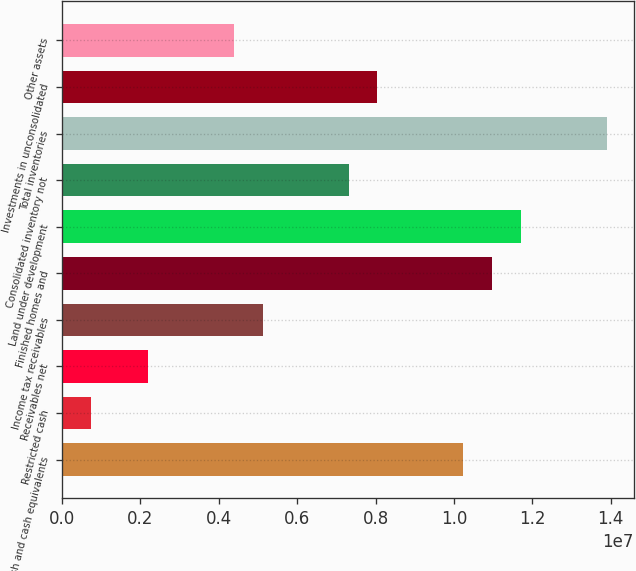Convert chart to OTSL. <chart><loc_0><loc_0><loc_500><loc_500><bar_chart><fcel>Cash and cash equivalents<fcel>Restricted cash<fcel>Receivables net<fcel>Income tax receivables<fcel>Finished homes and<fcel>Land under development<fcel>Consolidated inventory not<fcel>Total inventories<fcel>Investments in unconsolidated<fcel>Other assets<nl><fcel>1.02394e+07<fcel>734446<fcel>2.19674e+06<fcel>5.12134e+06<fcel>1.09705e+07<fcel>1.17017e+07<fcel>7.31479e+06<fcel>1.38951e+07<fcel>8.04594e+06<fcel>4.39019e+06<nl></chart> 